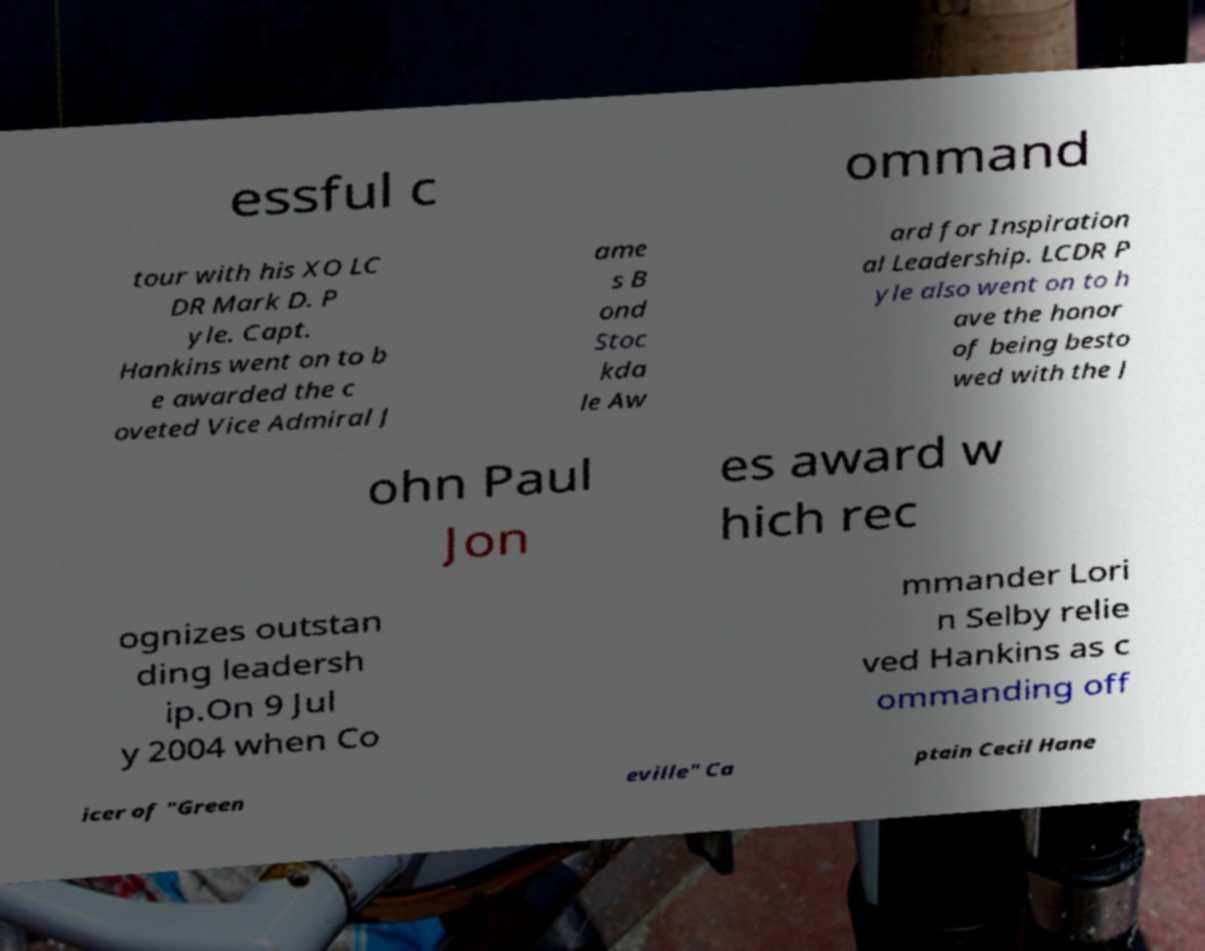I need the written content from this picture converted into text. Can you do that? essful c ommand tour with his XO LC DR Mark D. P yle. Capt. Hankins went on to b e awarded the c oveted Vice Admiral J ame s B ond Stoc kda le Aw ard for Inspiration al Leadership. LCDR P yle also went on to h ave the honor of being besto wed with the J ohn Paul Jon es award w hich rec ognizes outstan ding leadersh ip.On 9 Jul y 2004 when Co mmander Lori n Selby relie ved Hankins as c ommanding off icer of "Green eville" Ca ptain Cecil Hane 